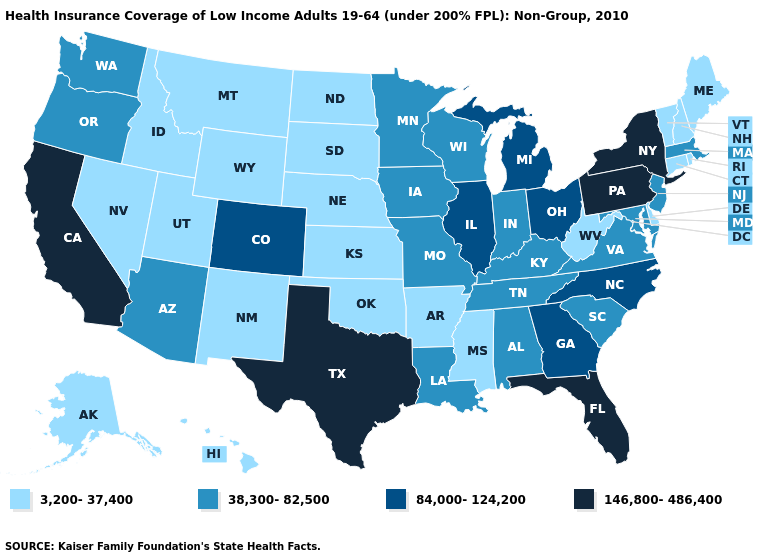Name the states that have a value in the range 38,300-82,500?
Quick response, please. Alabama, Arizona, Indiana, Iowa, Kentucky, Louisiana, Maryland, Massachusetts, Minnesota, Missouri, New Jersey, Oregon, South Carolina, Tennessee, Virginia, Washington, Wisconsin. Among the states that border Nevada , does California have the highest value?
Answer briefly. Yes. Does the first symbol in the legend represent the smallest category?
Quick response, please. Yes. Does the map have missing data?
Give a very brief answer. No. Does Hawaii have the lowest value in the USA?
Quick response, please. Yes. Among the states that border Tennessee , which have the highest value?
Short answer required. Georgia, North Carolina. What is the value of Virginia?
Write a very short answer. 38,300-82,500. Name the states that have a value in the range 146,800-486,400?
Keep it brief. California, Florida, New York, Pennsylvania, Texas. Name the states that have a value in the range 146,800-486,400?
Short answer required. California, Florida, New York, Pennsylvania, Texas. What is the lowest value in the USA?
Short answer required. 3,200-37,400. What is the value of New Mexico?
Keep it brief. 3,200-37,400. Name the states that have a value in the range 146,800-486,400?
Concise answer only. California, Florida, New York, Pennsylvania, Texas. What is the value of Colorado?
Answer briefly. 84,000-124,200. Does Missouri have the highest value in the USA?
Keep it brief. No. Name the states that have a value in the range 84,000-124,200?
Keep it brief. Colorado, Georgia, Illinois, Michigan, North Carolina, Ohio. 